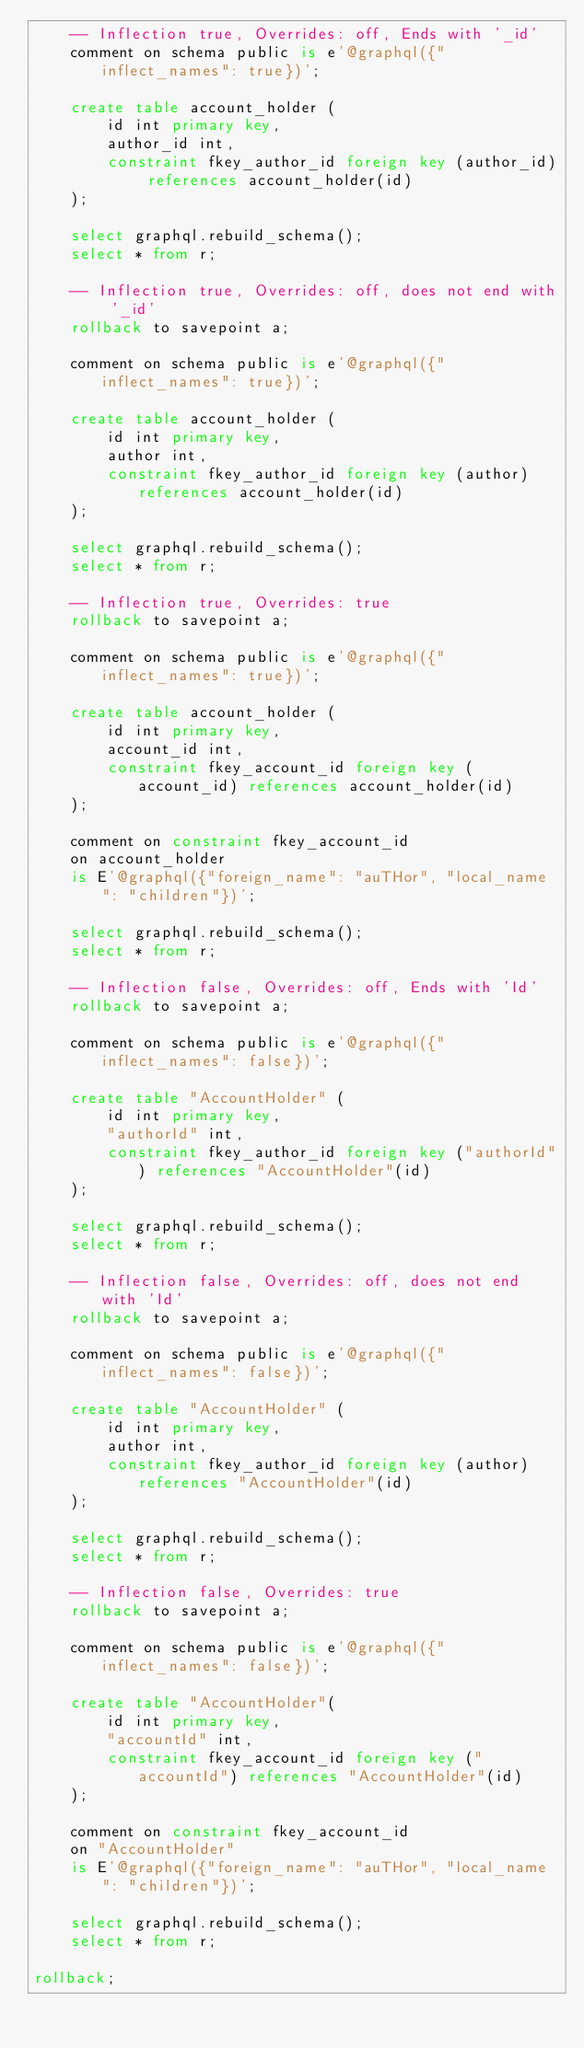<code> <loc_0><loc_0><loc_500><loc_500><_SQL_>    -- Inflection true, Overrides: off, Ends with '_id'
    comment on schema public is e'@graphql({"inflect_names": true})';

    create table account_holder (
        id int primary key,
        author_id int,
        constraint fkey_author_id foreign key (author_id) references account_holder(id)
    );

    select graphql.rebuild_schema();
    select * from r;

    -- Inflection true, Overrides: off, does not end with '_id'
    rollback to savepoint a;

    comment on schema public is e'@graphql({"inflect_names": true})';

    create table account_holder (
        id int primary key,
        author int,
        constraint fkey_author_id foreign key (author) references account_holder(id)
    );

    select graphql.rebuild_schema();
    select * from r;

    -- Inflection true, Overrides: true
    rollback to savepoint a;

    comment on schema public is e'@graphql({"inflect_names": true})';

    create table account_holder (
        id int primary key,
        account_id int,
        constraint fkey_account_id foreign key (account_id) references account_holder(id)
    );

    comment on constraint fkey_account_id
    on account_holder
    is E'@graphql({"foreign_name": "auTHor", "local_name": "children"})';

    select graphql.rebuild_schema();
    select * from r;

    -- Inflection false, Overrides: off, Ends with 'Id'
    rollback to savepoint a;

    comment on schema public is e'@graphql({"inflect_names": false})';

    create table "AccountHolder" (
        id int primary key,
        "authorId" int,
        constraint fkey_author_id foreign key ("authorId") references "AccountHolder"(id)
    );

    select graphql.rebuild_schema();
    select * from r;

    -- Inflection false, Overrides: off, does not end with 'Id'
    rollback to savepoint a;

    comment on schema public is e'@graphql({"inflect_names": false})';

    create table "AccountHolder" (
        id int primary key,
        author int,
        constraint fkey_author_id foreign key (author) references "AccountHolder"(id)
    );

    select graphql.rebuild_schema();
    select * from r;

    -- Inflection false, Overrides: true
    rollback to savepoint a;

    comment on schema public is e'@graphql({"inflect_names": false})';

    create table "AccountHolder"(
        id int primary key,
        "accountId" int,
        constraint fkey_account_id foreign key ("accountId") references "AccountHolder"(id)
    );

    comment on constraint fkey_account_id
    on "AccountHolder"
    is E'@graphql({"foreign_name": "auTHor", "local_name": "children"})';

    select graphql.rebuild_schema();
    select * from r;

rollback;
</code> 